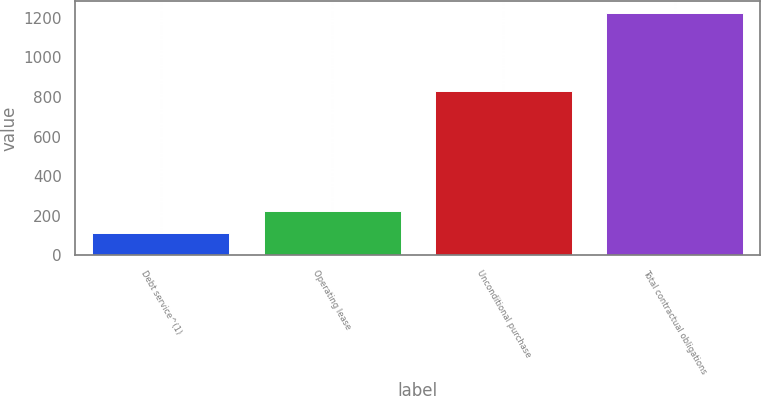<chart> <loc_0><loc_0><loc_500><loc_500><bar_chart><fcel>Debt service^(1)<fcel>Operating lease<fcel>Unconditional purchase<fcel>Total contractual obligations<nl><fcel>110.9<fcel>222.14<fcel>831.9<fcel>1223.3<nl></chart> 